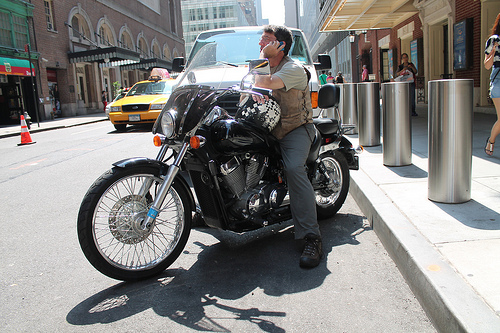On which side of the photo is the woman? The woman is positioned on the right side of the photo, partially out of frame. 